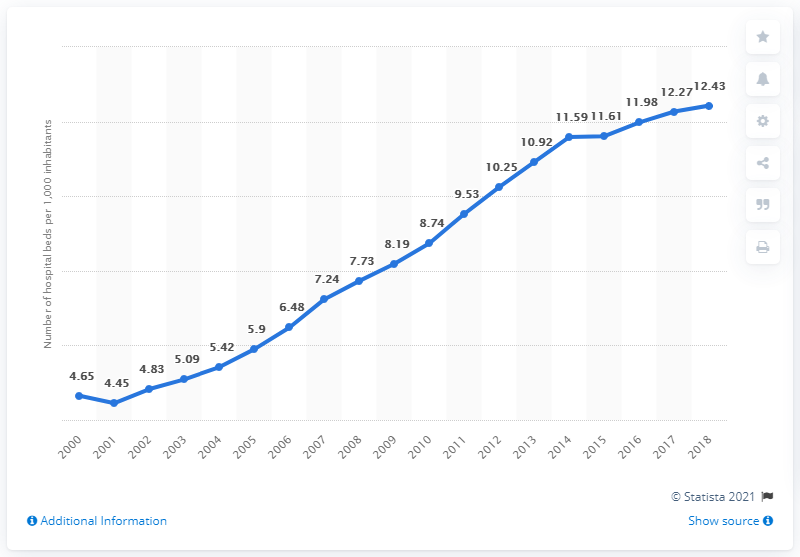Point out several critical features in this image. In 2018, there were 12.43 hospital beds available for every 1,000 South Koreans. 